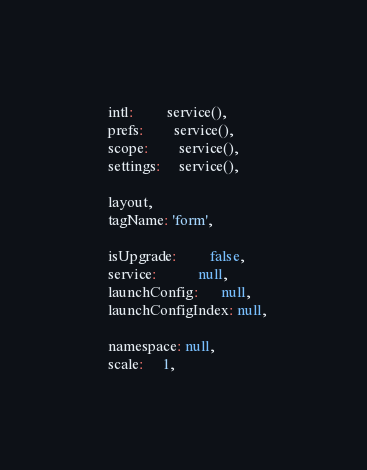<code> <loc_0><loc_0><loc_500><loc_500><_JavaScript_>  intl:         service(),
  prefs:        service(),
  scope:        service(),
  settings:     service(),

  layout,
  tagName: 'form',

  isUpgrade:         false,
  service:           null,
  launchConfig:      null,
  launchConfigIndex: null,

  namespace: null,
  scale:     1,</code> 